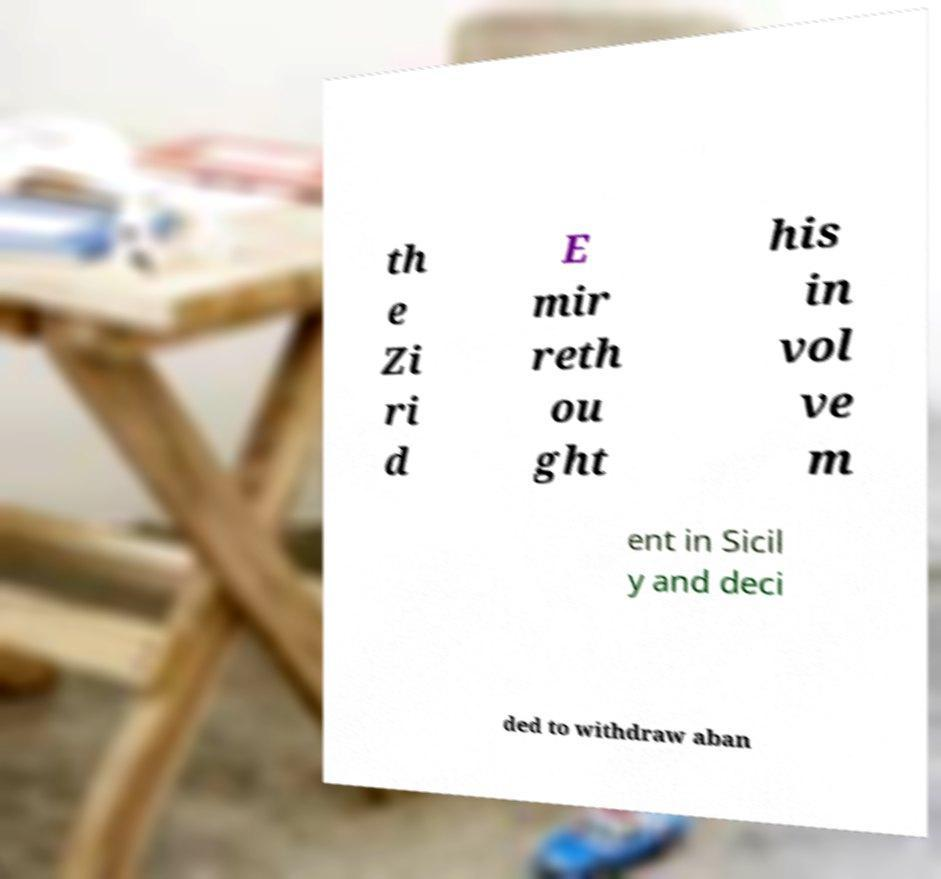What messages or text are displayed in this image? I need them in a readable, typed format. th e Zi ri d E mir reth ou ght his in vol ve m ent in Sicil y and deci ded to withdraw aban 